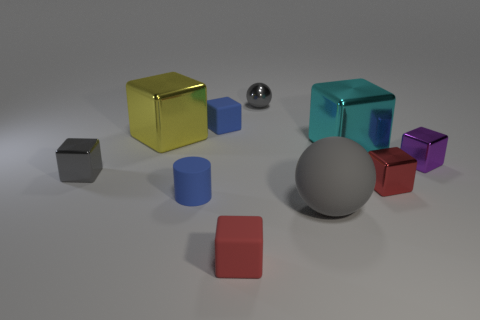Subtract all purple blocks. How many blocks are left? 6 Subtract all tiny gray shiny blocks. How many blocks are left? 6 Subtract all red cubes. Subtract all blue balls. How many cubes are left? 5 Subtract all cylinders. How many objects are left? 9 Subtract all tiny gray metallic spheres. Subtract all large green shiny cylinders. How many objects are left? 9 Add 4 blue matte blocks. How many blue matte blocks are left? 5 Add 3 large brown shiny blocks. How many large brown shiny blocks exist? 3 Subtract 0 red cylinders. How many objects are left? 10 